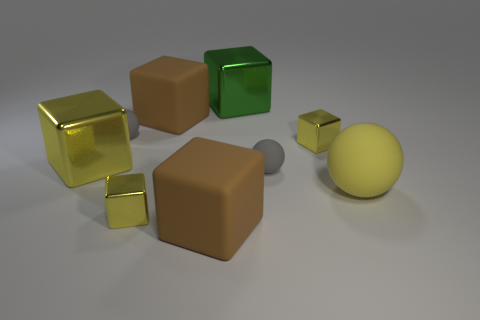There is a large metallic object that is the same color as the large matte sphere; what is its shape?
Offer a very short reply. Cube. How many yellow rubber balls have the same size as the green metallic thing?
Your response must be concise. 1. What number of big green blocks are right of the large green thing?
Provide a succinct answer. 0. What material is the small gray object that is to the left of the brown cube in front of the large ball made of?
Provide a succinct answer. Rubber. Is there a tiny rubber sphere that has the same color as the big rubber ball?
Provide a succinct answer. No. The green cube that is made of the same material as the big yellow cube is what size?
Your answer should be very brief. Large. Is there anything else of the same color as the large matte sphere?
Offer a very short reply. Yes. There is a big shiny object that is behind the large yellow cube; what color is it?
Your response must be concise. Green. Are there any yellow balls in front of the brown rubber object behind the tiny yellow thing that is right of the large green thing?
Your answer should be compact. Yes. Are there more big cubes that are behind the big green cube than big metal blocks?
Provide a succinct answer. No. 